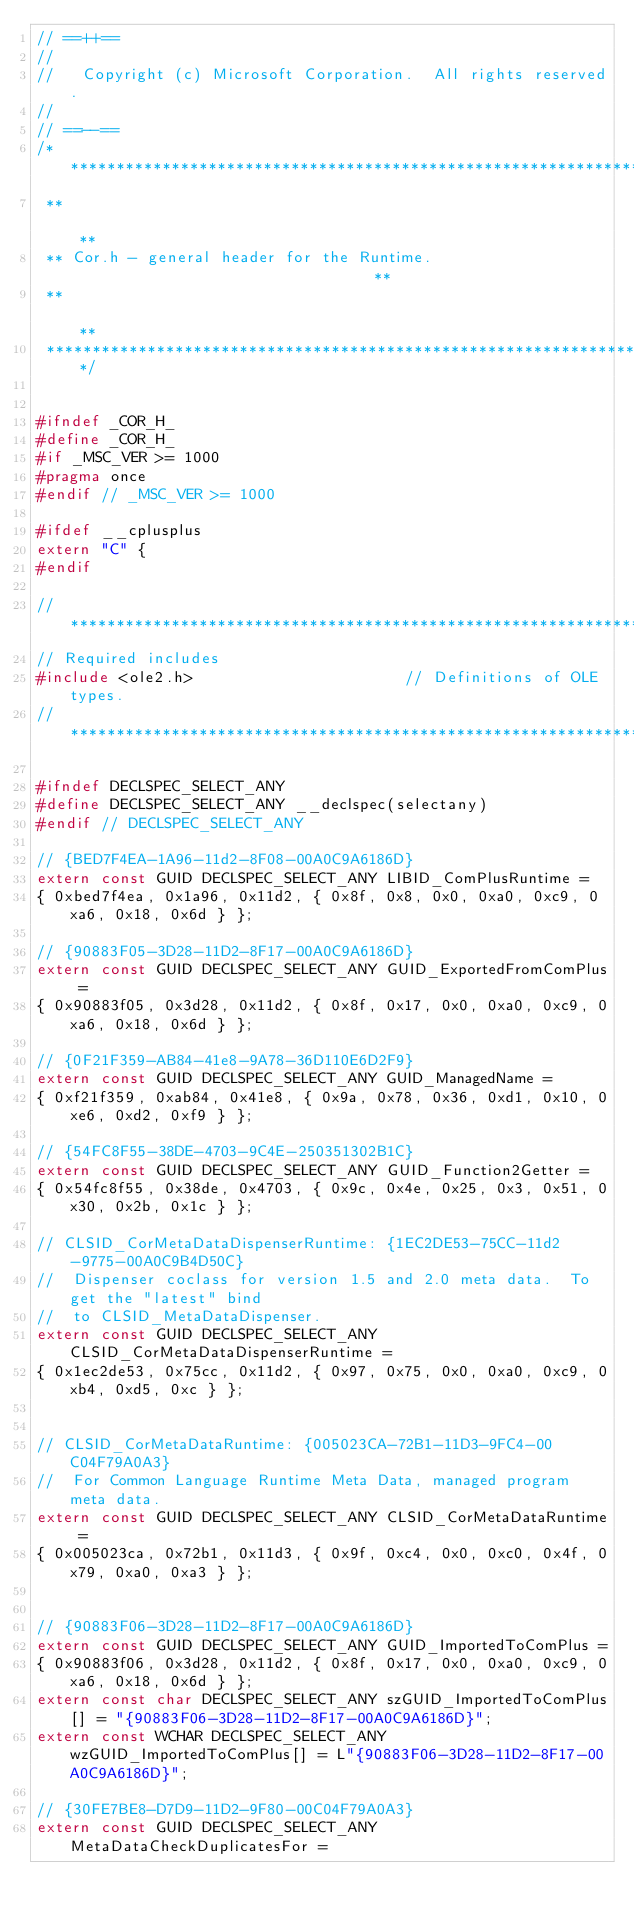Convert code to text. <code><loc_0><loc_0><loc_500><loc_500><_C_>// ==++==
// 
//   Copyright (c) Microsoft Corporation.  All rights reserved.
// 
// ==--==
/*****************************************************************************
 **                                                                         **
 ** Cor.h - general header for the Runtime.                                 **
 **                                                                         **
 *****************************************************************************/


#ifndef _COR_H_
#define _COR_H_
#if _MSC_VER >= 1000
#pragma once
#endif // _MSC_VER >= 1000

#ifdef __cplusplus
extern "C" {
#endif

//*****************************************************************************
// Required includes
#include <ole2.h>                       // Definitions of OLE types.    
//*****************************************************************************

#ifndef DECLSPEC_SELECT_ANY
#define DECLSPEC_SELECT_ANY __declspec(selectany)
#endif // DECLSPEC_SELECT_ANY

// {BED7F4EA-1A96-11d2-8F08-00A0C9A6186D}
extern const GUID DECLSPEC_SELECT_ANY LIBID_ComPlusRuntime = 
{ 0xbed7f4ea, 0x1a96, 0x11d2, { 0x8f, 0x8, 0x0, 0xa0, 0xc9, 0xa6, 0x18, 0x6d } };

// {90883F05-3D28-11D2-8F17-00A0C9A6186D}
extern const GUID DECLSPEC_SELECT_ANY GUID_ExportedFromComPlus = 
{ 0x90883f05, 0x3d28, 0x11d2, { 0x8f, 0x17, 0x0, 0xa0, 0xc9, 0xa6, 0x18, 0x6d } };

// {0F21F359-AB84-41e8-9A78-36D110E6D2F9}
extern const GUID DECLSPEC_SELECT_ANY GUID_ManagedName = 
{ 0xf21f359, 0xab84, 0x41e8, { 0x9a, 0x78, 0x36, 0xd1, 0x10, 0xe6, 0xd2, 0xf9 } };

// {54FC8F55-38DE-4703-9C4E-250351302B1C}
extern const GUID DECLSPEC_SELECT_ANY GUID_Function2Getter = 
{ 0x54fc8f55, 0x38de, 0x4703, { 0x9c, 0x4e, 0x25, 0x3, 0x51, 0x30, 0x2b, 0x1c } };

// CLSID_CorMetaDataDispenserRuntime: {1EC2DE53-75CC-11d2-9775-00A0C9B4D50C}
//  Dispenser coclass for version 1.5 and 2.0 meta data.  To get the "latest" bind  
//  to CLSID_MetaDataDispenser. 
extern const GUID DECLSPEC_SELECT_ANY CLSID_CorMetaDataDispenserRuntime = 
{ 0x1ec2de53, 0x75cc, 0x11d2, { 0x97, 0x75, 0x0, 0xa0, 0xc9, 0xb4, 0xd5, 0xc } };


// CLSID_CorMetaDataRuntime: {005023CA-72B1-11D3-9FC4-00C04F79A0A3}
//  For Common Language Runtime Meta Data, managed program meta data.  
extern const GUID DECLSPEC_SELECT_ANY CLSID_CorMetaDataRuntime = 
{ 0x005023ca, 0x72b1, 0x11d3, { 0x9f, 0xc4, 0x0, 0xc0, 0x4f, 0x79, 0xa0, 0xa3 } };


// {90883F06-3D28-11D2-8F17-00A0C9A6186D}
extern const GUID DECLSPEC_SELECT_ANY GUID_ImportedToComPlus = 
{ 0x90883f06, 0x3d28, 0x11d2, { 0x8f, 0x17, 0x0, 0xa0, 0xc9, 0xa6, 0x18, 0x6d } };
extern const char DECLSPEC_SELECT_ANY szGUID_ImportedToComPlus[] = "{90883F06-3D28-11D2-8F17-00A0C9A6186D}";
extern const WCHAR DECLSPEC_SELECT_ANY wzGUID_ImportedToComPlus[] = L"{90883F06-3D28-11D2-8F17-00A0C9A6186D}";

// {30FE7BE8-D7D9-11D2-9F80-00C04F79A0A3}
extern const GUID DECLSPEC_SELECT_ANY MetaDataCheckDuplicatesFor =</code> 